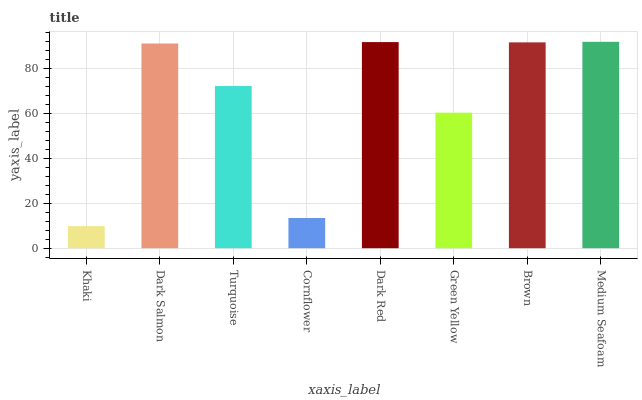Is Khaki the minimum?
Answer yes or no. Yes. Is Medium Seafoam the maximum?
Answer yes or no. Yes. Is Dark Salmon the minimum?
Answer yes or no. No. Is Dark Salmon the maximum?
Answer yes or no. No. Is Dark Salmon greater than Khaki?
Answer yes or no. Yes. Is Khaki less than Dark Salmon?
Answer yes or no. Yes. Is Khaki greater than Dark Salmon?
Answer yes or no. No. Is Dark Salmon less than Khaki?
Answer yes or no. No. Is Dark Salmon the high median?
Answer yes or no. Yes. Is Turquoise the low median?
Answer yes or no. Yes. Is Dark Red the high median?
Answer yes or no. No. Is Medium Seafoam the low median?
Answer yes or no. No. 